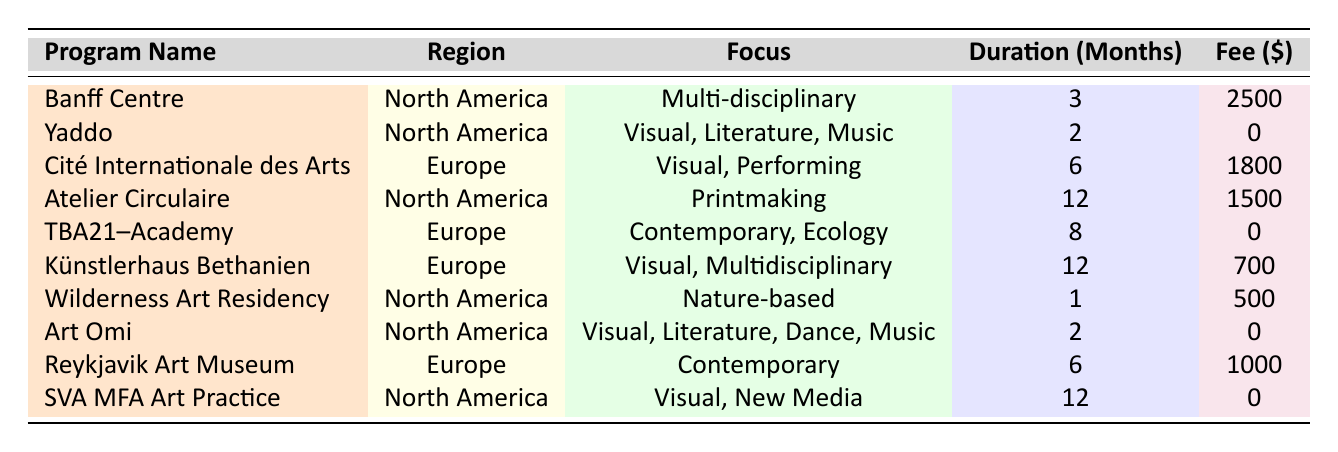What is the total fee for all artist residencies in North America? The fees for North America residencies are: Banff Centre ($2500) + Yaddo ($0) + Atelier Circulaire ($1500) + Wilderness Art Residency ($500) + Art Omi ($0) + SVA MFA Art Practice ($0) = $2500 + 0 + 1500 + 500 + 0 + 0 = $4500
Answer: $4500 Which region has the longest duration for artist residencies? The maximum duration among the residencies is 12 months, found in the North America residencies (Atelier Circulaire and SVA MFA Art Practice) and in Europe (Künstlerhaus Bethanien). Thus, both regions have the longest duration.
Answer: Both North America and Europe How many artist residencies offer scholarships in Europe? There are three programs in Europe: Cité Internationale des Arts (yes), TBA21–Academy (yes), and Künstlerhaus Bethanien (no). Therefore, 2 of the 3 programs offer scholarships.
Answer: 2 What is the average fee for artist residencies in Europe? The fees for Europe residencies are: Cité Internationale des Arts ($1800) + TBA21–Academy ($0) + Künstlerhaus Bethanien ($700) + Reykjavik Art Museum ($1000). Total = $1800 + 0 + 700 + 1000 = $3500. With 4 residencies, the average fee is $3500 / 4 = $875.
Answer: $875 Is there any artist residency that has no fee and offers a scholarship in North America? Yes, both Yaddo and SVA MFA Art Practice offer scholarships and have no fees.
Answer: Yes Which program has the highest fee in North America, and what is that fee? The program with the highest fee in North America is the Banff Centre for Arts and Creativity, which has a fee of $2500.
Answer: Banff Centre for Arts and Creativity, $2500 How many artist residencies have a duration of less than 3 months? From the table, only the Wilderness Art Residency lasts for 1 month and the others are 2 months or longer. Therefore, there is 1 residency less than 3 months.
Answer: 1 What percentage of the artist residencies in Europe are focused on contemporary art? There are 4 artist residencies in Europe: 1 (TBA21–Academy) and 1 (Reykjavik Art Museum) focus on contemporary art, which is 2 out of 4. Thus, the percentage of residencies focused on contemporary art is (2/4) * 100 = 50%.
Answer: 50% Which region has the most artist residencies total, and how many? North America has 6 artist residencies (Banff Centre, Yaddo, Atelier Circulaire, Wilderness Art Residency, Art Omi, SVA MFA Art Practice) while Europe has 4 (Cité Internationale des Arts, TBA21–Academy, Künstlerhaus Bethanien, Reykjavik Art Museum).
Answer: North America, 6 What is the difference in duration between the longest and shortest artist residencies? The longest duration is 12 months (Atelier Circulaire and Künstlerhaus Bethanien) and the shortest is 1 month (Wilderness Art Residency). Thus, the difference is 12 - 1 = 11 months.
Answer: 11 months 